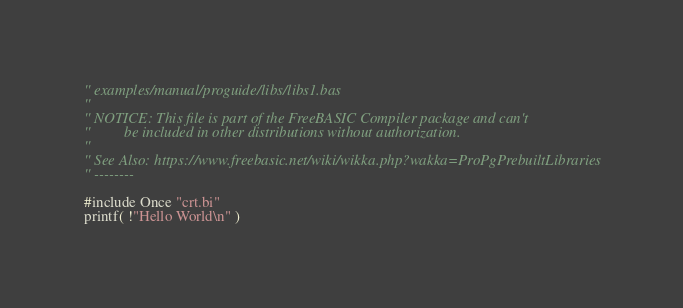<code> <loc_0><loc_0><loc_500><loc_500><_VisualBasic_>'' examples/manual/proguide/libs/libs1.bas
''
'' NOTICE: This file is part of the FreeBASIC Compiler package and can't
''         be included in other distributions without authorization.
''
'' See Also: https://www.freebasic.net/wiki/wikka.php?wakka=ProPgPrebuiltLibraries
'' --------

#include Once "crt.bi"
printf( !"Hello World\n" )
</code> 